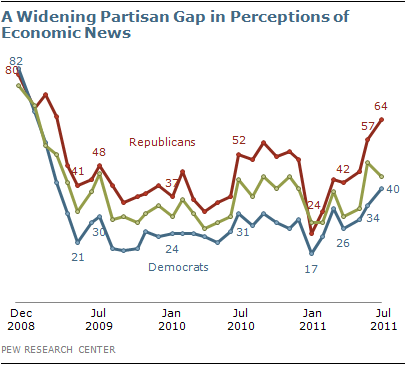Identify some key points in this picture. The number of lines in the graph is three. On average, the lowest percentage of each party is 20.5%. 